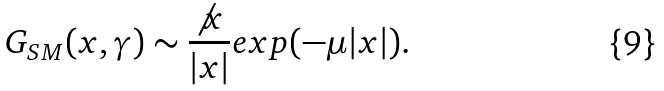<formula> <loc_0><loc_0><loc_500><loc_500>G _ { S M } ( x , \gamma ) \sim \frac { \not x } { | x | } e x p ( - \mu | x | ) .</formula> 